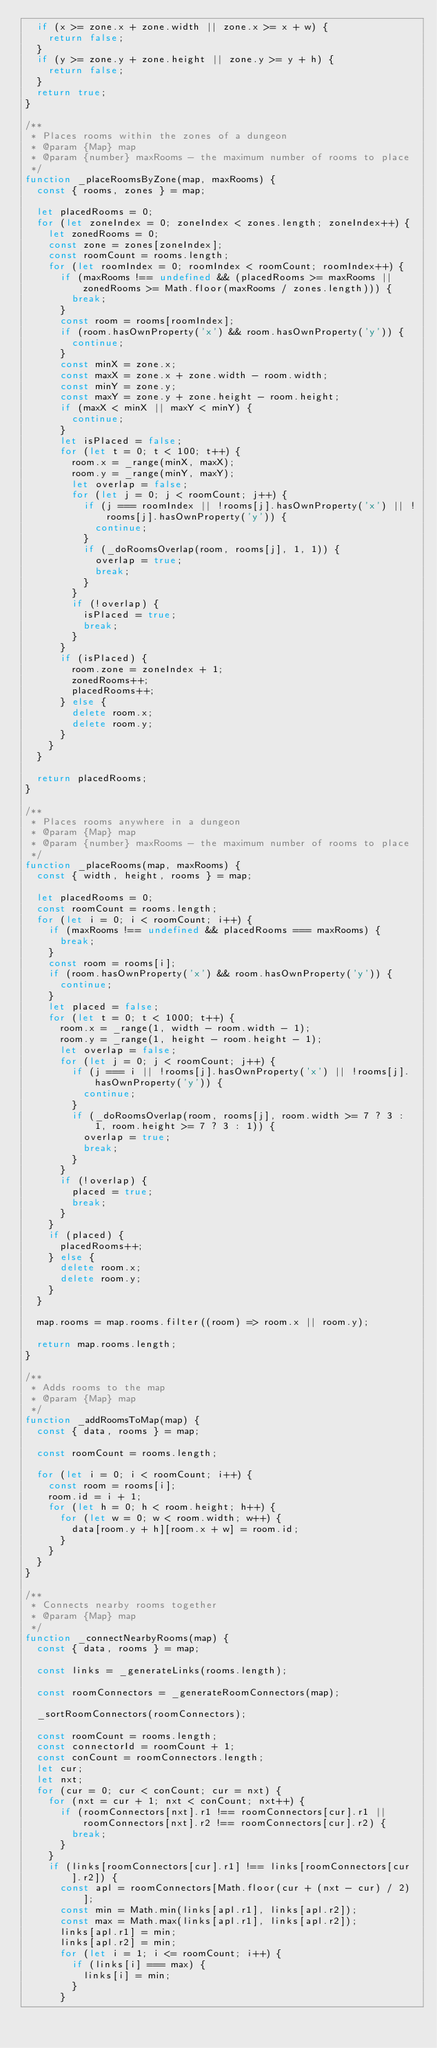Convert code to text. <code><loc_0><loc_0><loc_500><loc_500><_JavaScript_>  if (x >= zone.x + zone.width || zone.x >= x + w) {
    return false;
  }
  if (y >= zone.y + zone.height || zone.y >= y + h) {
    return false;
  }
  return true;
}

/**
 * Places rooms within the zones of a dungeon
 * @param {Map} map
 * @param {number} maxRooms - the maximum number of rooms to place
 */
function _placeRoomsByZone(map, maxRooms) {
  const { rooms, zones } = map;

  let placedRooms = 0;
  for (let zoneIndex = 0; zoneIndex < zones.length; zoneIndex++) {
    let zonedRooms = 0;
    const zone = zones[zoneIndex];
    const roomCount = rooms.length;
    for (let roomIndex = 0; roomIndex < roomCount; roomIndex++) {
      if (maxRooms !== undefined && (placedRooms >= maxRooms || zonedRooms >= Math.floor(maxRooms / zones.length))) {
        break;
      }
      const room = rooms[roomIndex];
      if (room.hasOwnProperty('x') && room.hasOwnProperty('y')) {
        continue;
      }
      const minX = zone.x;
      const maxX = zone.x + zone.width - room.width;
      const minY = zone.y;
      const maxY = zone.y + zone.height - room.height;
      if (maxX < minX || maxY < minY) {
        continue;
      }
      let isPlaced = false;
      for (let t = 0; t < 100; t++) {
        room.x = _range(minX, maxX);
        room.y = _range(minY, maxY);
        let overlap = false;
        for (let j = 0; j < roomCount; j++) {
          if (j === roomIndex || !rooms[j].hasOwnProperty('x') || !rooms[j].hasOwnProperty('y')) {
            continue;
          }
          if (_doRoomsOverlap(room, rooms[j], 1, 1)) {
            overlap = true;
            break;
          }
        }
        if (!overlap) {
          isPlaced = true;
          break;
        }
      }
      if (isPlaced) {
        room.zone = zoneIndex + 1;
        zonedRooms++;
        placedRooms++;
      } else {
        delete room.x;
        delete room.y;
      }
    }
  }

  return placedRooms;
}

/**
 * Places rooms anywhere in a dungeon
 * @param {Map} map
 * @param {number} maxRooms - the maximum number of rooms to place
 */
function _placeRooms(map, maxRooms) {
  const { width, height, rooms } = map;

  let placedRooms = 0;
  const roomCount = rooms.length;
  for (let i = 0; i < roomCount; i++) {
    if (maxRooms !== undefined && placedRooms === maxRooms) {
      break;
    }
    const room = rooms[i];
    if (room.hasOwnProperty('x') && room.hasOwnProperty('y')) {
      continue;
    }
    let placed = false;
    for (let t = 0; t < 1000; t++) {
      room.x = _range(1, width - room.width - 1);
      room.y = _range(1, height - room.height - 1);
      let overlap = false;
      for (let j = 0; j < roomCount; j++) {
        if (j === i || !rooms[j].hasOwnProperty('x') || !rooms[j].hasOwnProperty('y')) {
          continue;
        }
        if (_doRoomsOverlap(room, rooms[j], room.width >= 7 ? 3 : 1, room.height >= 7 ? 3 : 1)) {
          overlap = true;
          break;
        }
      }
      if (!overlap) {
        placed = true;
        break;
      }
    }
    if (placed) {
      placedRooms++;
    } else {
      delete room.x;
      delete room.y;
    }
  }

  map.rooms = map.rooms.filter((room) => room.x || room.y);

  return map.rooms.length;
}

/**
 * Adds rooms to the map
 * @param {Map} map
 */
function _addRoomsToMap(map) {
  const { data, rooms } = map;

  const roomCount = rooms.length;

  for (let i = 0; i < roomCount; i++) {
    const room = rooms[i];
    room.id = i + 1;
    for (let h = 0; h < room.height; h++) {
      for (let w = 0; w < room.width; w++) {
        data[room.y + h][room.x + w] = room.id;
      }
    }
  }
}

/**
 * Connects nearby rooms together
 * @param {Map} map
 */
function _connectNearbyRooms(map) {
  const { data, rooms } = map;

  const links = _generateLinks(rooms.length);

  const roomConnectors = _generateRoomConnectors(map);

  _sortRoomConnectors(roomConnectors);

  const roomCount = rooms.length;
  const connectorId = roomCount + 1;
  const conCount = roomConnectors.length;
  let cur;
  let nxt;
  for (cur = 0; cur < conCount; cur = nxt) {
    for (nxt = cur + 1; nxt < conCount; nxt++) {
      if (roomConnectors[nxt].r1 !== roomConnectors[cur].r1 || roomConnectors[nxt].r2 !== roomConnectors[cur].r2) {
        break;
      }
    }
    if (links[roomConnectors[cur].r1] !== links[roomConnectors[cur].r2]) {
      const apl = roomConnectors[Math.floor(cur + (nxt - cur) / 2)];
      const min = Math.min(links[apl.r1], links[apl.r2]);
      const max = Math.max(links[apl.r1], links[apl.r2]);
      links[apl.r1] = min;
      links[apl.r2] = min;
      for (let i = 1; i <= roomCount; i++) {
        if (links[i] === max) {
          links[i] = min;
        }
      }</code> 